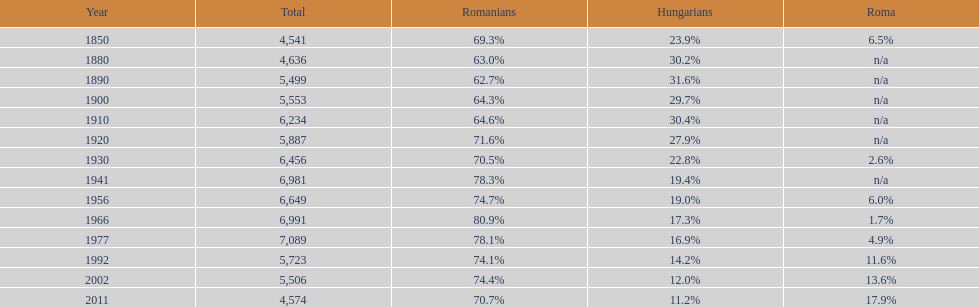In how many occurrences did the total population surpass or equal 6,000? 6. 